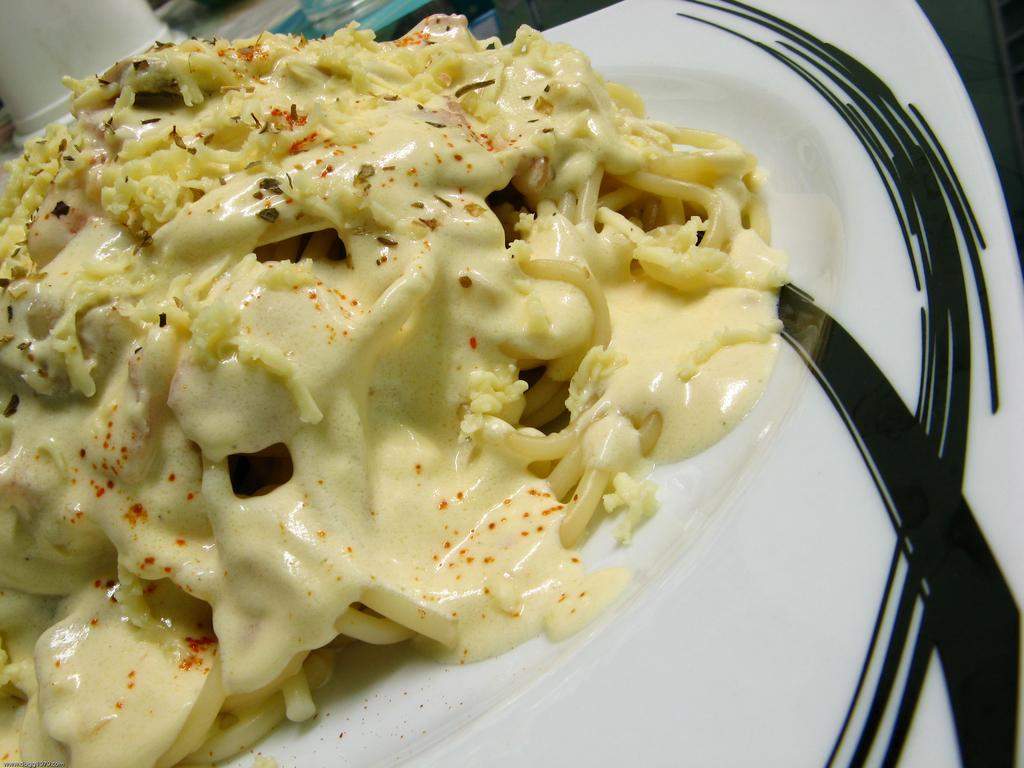What is present on the plate in the image? The plate has food on it. Can you describe the plate in the image? There is a plate in the image, and it has food on it. What type of laborer is depicted working at the airport in the image? There is no airport or laborer present in the image; it only features a plate with food on it. 